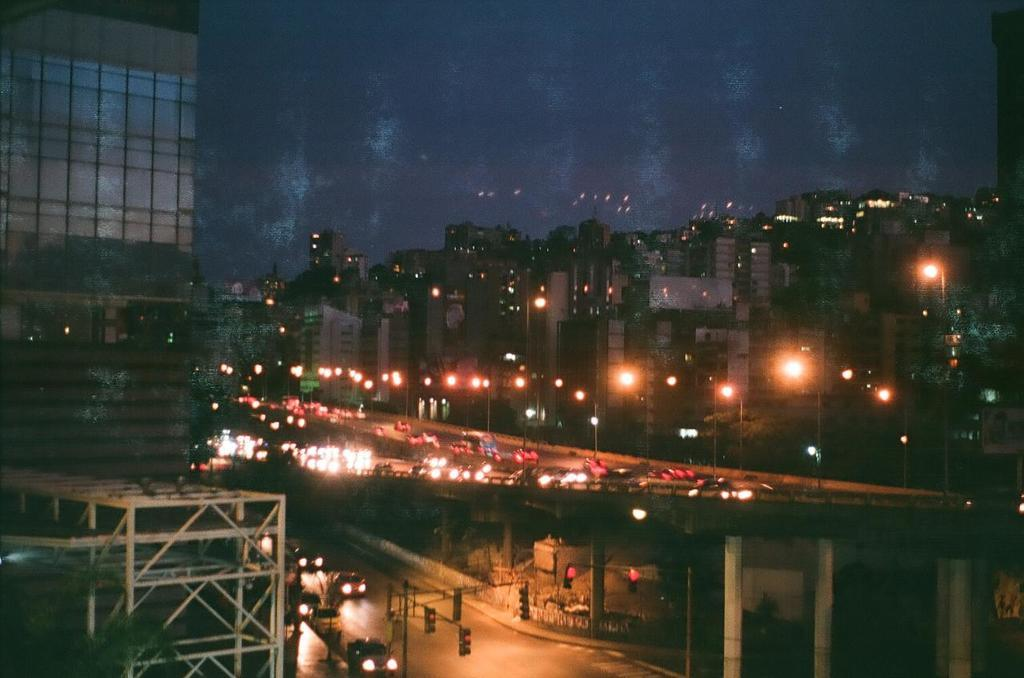What type of structures can be seen in the image? There are buildings in the image. What other objects are present in the image? There are light poles, a bridge, vehicles, pillars, and traffic lights in the image. Can you describe the background of the image? The sky is visible in the background of the image. Where is the crowd gathered in the image? There is no crowd present in the image. Can you see a turkey crossing the road in the image? There is no turkey present in the image. 